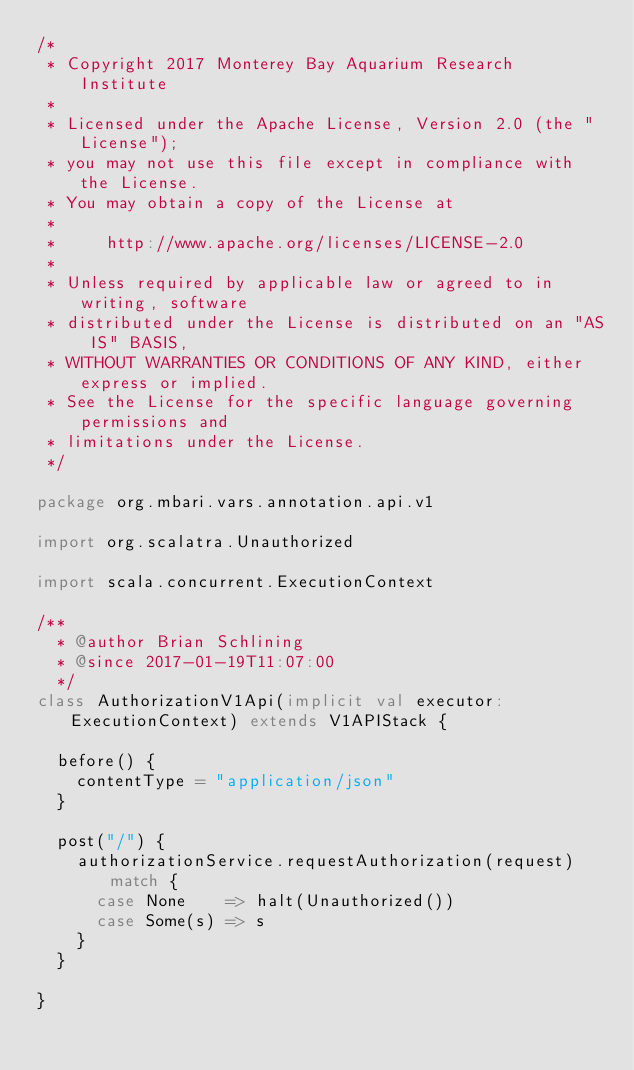Convert code to text. <code><loc_0><loc_0><loc_500><loc_500><_Scala_>/*
 * Copyright 2017 Monterey Bay Aquarium Research Institute
 *
 * Licensed under the Apache License, Version 2.0 (the "License");
 * you may not use this file except in compliance with the License.
 * You may obtain a copy of the License at
 *
 *     http://www.apache.org/licenses/LICENSE-2.0
 *
 * Unless required by applicable law or agreed to in writing, software
 * distributed under the License is distributed on an "AS IS" BASIS,
 * WITHOUT WARRANTIES OR CONDITIONS OF ANY KIND, either express or implied.
 * See the License for the specific language governing permissions and
 * limitations under the License.
 */

package org.mbari.vars.annotation.api.v1

import org.scalatra.Unauthorized

import scala.concurrent.ExecutionContext

/**
  * @author Brian Schlining
  * @since 2017-01-19T11:07:00
  */
class AuthorizationV1Api(implicit val executor: ExecutionContext) extends V1APIStack {

  before() {
    contentType = "application/json"
  }

  post("/") {
    authorizationService.requestAuthorization(request) match {
      case None    => halt(Unauthorized())
      case Some(s) => s
    }
  }

}
</code> 